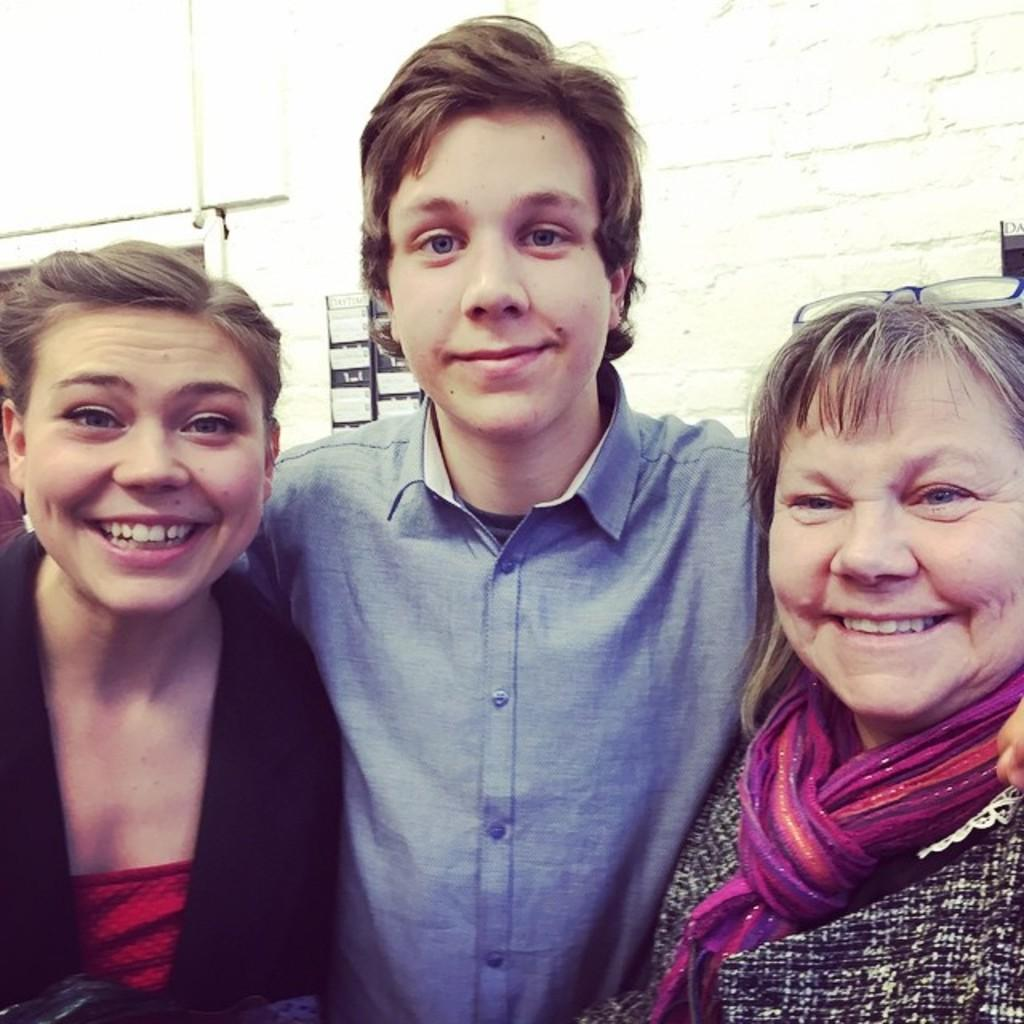How many people are present in the image? There are three people in the image: a man and two women. What are the expressions on the faces of the people in the image? The man and women are smiling in the image. What can be seen in the background of the image? There is a board on a wall in the background of the image. What color is the plastic orange in the image? There is no plastic orange present in the image. What type of request can be seen written on the board in the image? There is no request visible on the board in the image; it is not mentioned in the provided facts. 